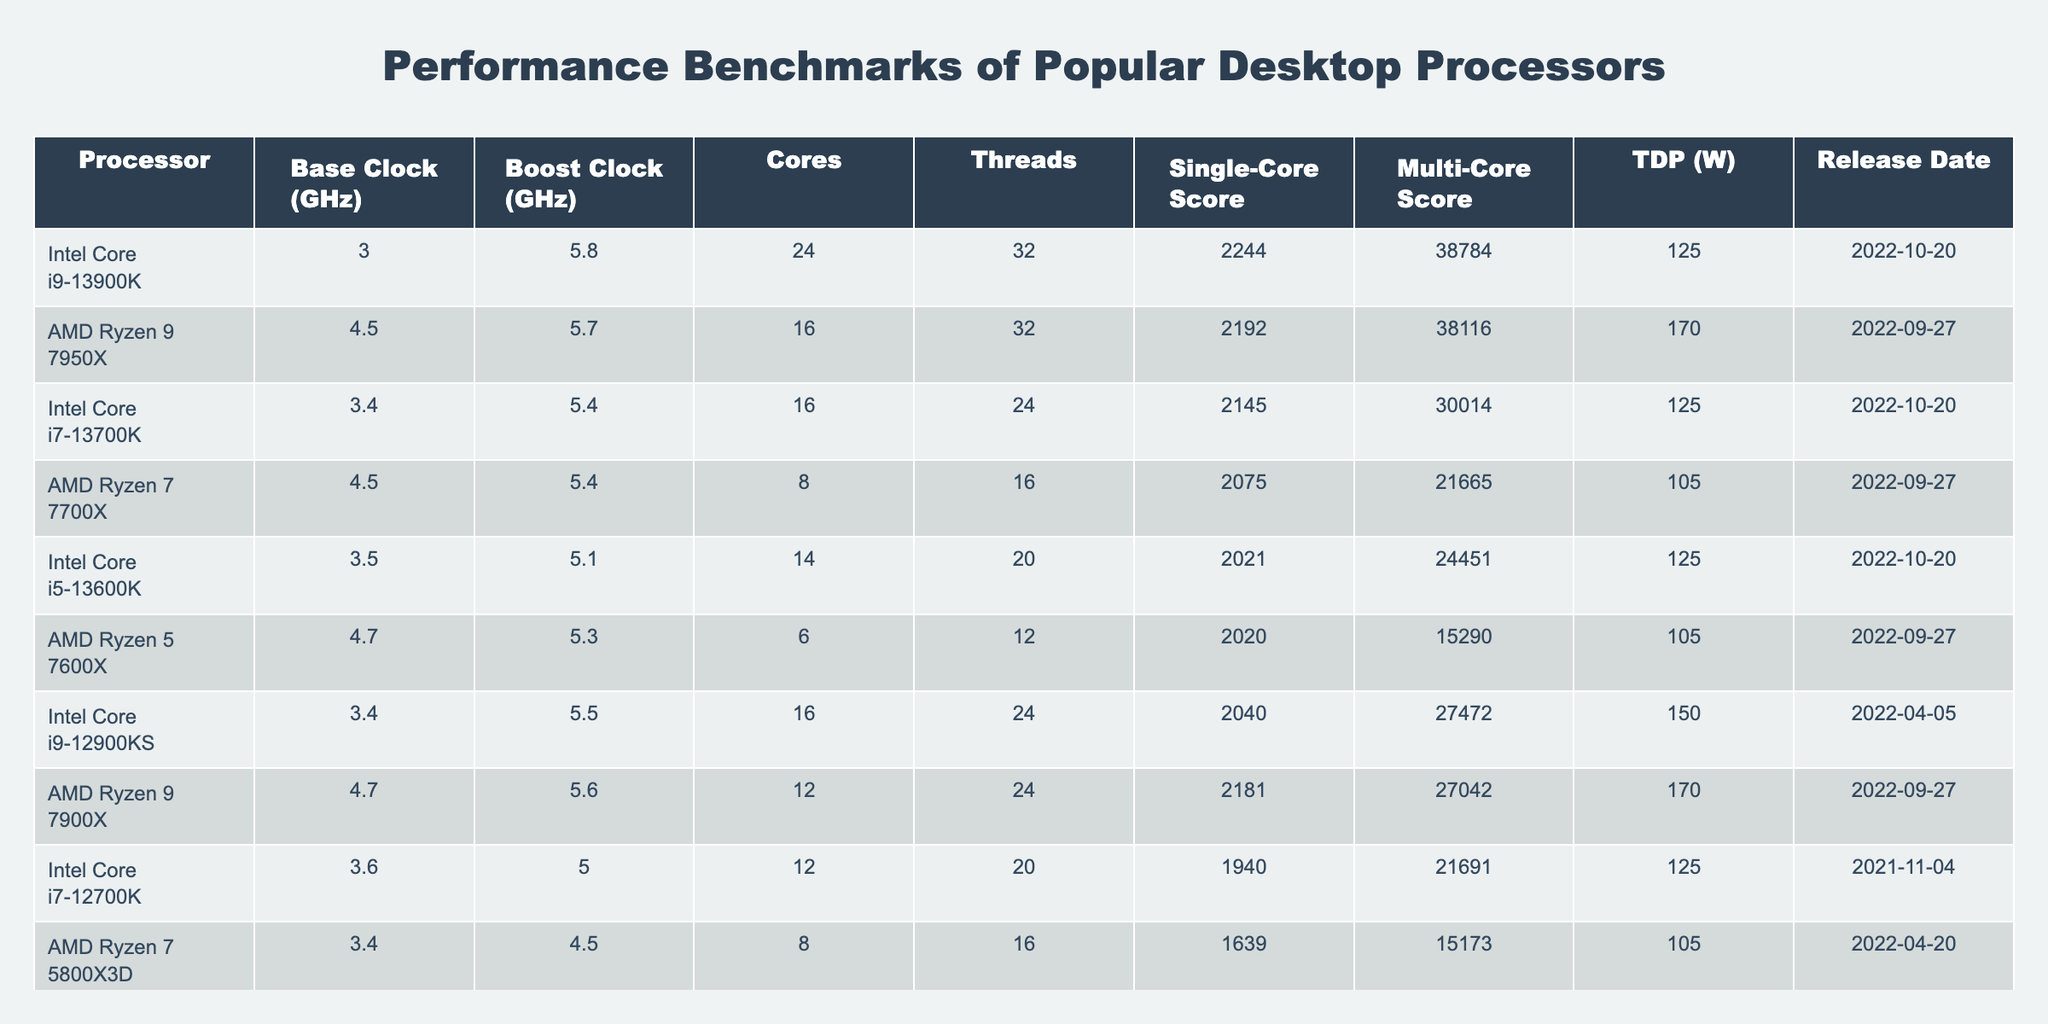What is the base clock speed of the Intel Core i9-13900K? The table lists the specifications of the Intel Core i9-13900K, showing that its base clock speed is 3.0 GHz.
Answer: 3.0 GHz Which processor has the highest single-core score? By examining the single-core scores, the Intel Core i9-13900K has the highest score at 2244, compared to other processors listed.
Answer: Intel Core i9-13900K How many threads does the AMD Ryzen 7 7700X have? The AMD Ryzen 7 7700X is listed in the table along with its specifications, which indicate it has 16 threads.
Answer: 16 What is the difference in multi-core scores between the Intel Core i5-13600K and the AMD Ryzen 5 7600X? The Intel Core i5-13600K has a multi-core score of 24451, while the AMD Ryzen 5 7600X has a score of 15290. The difference is 24451 - 15290 = 9161.
Answer: 9161 Which processor has a higher TDP, the AMD Ryzen 9 7950X or the Intel Core i7-13700K? Comparing the TDPs, the AMD Ryzen 9 7950X has a TDP of 170 W, while the Intel Core i7-13700K has a TDP of 125 W. Since 170 is greater than 125, the Ryzen 9 7950X has a higher TDP.
Answer: AMD Ryzen 9 7950X What is the average base clock speed of all listed processors? The base clock speeds are 3.0, 4.5, 3.4, 4.5, 3.5, 4.7, 3.4, 4.7, 3.6, 3.4 GHz. The total is 3.0 + 4.5 + 3.4 + 4.5 + 3.5 + 4.7 + 3.4 + 4.7 + 3.6 + 3.4 = 39.7 GHz. There are 10 processors, so the average is 39.7 / 10 = 3.97 GHz.
Answer: 3.97 GHz Is it true that the Intel Core i9-12900KS was released after the AMD Ryzen 7 5800X3D? Checking the release dates, the Intel Core i9-12900KS was released on 2022-04-05, while the AMD Ryzen 7 5800X3D was released on 2022-04-20. Since April 5th is before April 20th, the statement is false.
Answer: False Which processor has the highest boost clock speed? The boost clock for the Intel Core i9-13900K is 5.8 GHz, which is higher than the others. Therefore, it has the highest boost clock speed among the listed processors.
Answer: Intel Core i9-13900K What is the total number of cores across all listed processors? The number of cores are 24, 16, 16, 8, 14, 6, 16, 12, 12, 8. Summing these yields: 24 + 16 + 16 + 8 + 14 + 6 + 16 + 12 + 12 + 8 = 132.
Answer: 132 Which processor has the lowest multi-core score? The AMD Ryzen 5 7600X has the lowest multi-core score of 15290 when compared to other processors in the table.
Answer: AMD Ryzen 5 7600X If you consider the TDP, which processor is the most power-efficient among them? The AMD Ryzen 5 7600X has the lowest TDP of 105 W, suggesting it is the most power-efficient processor in the table.
Answer: AMD Ryzen 5 7600X 